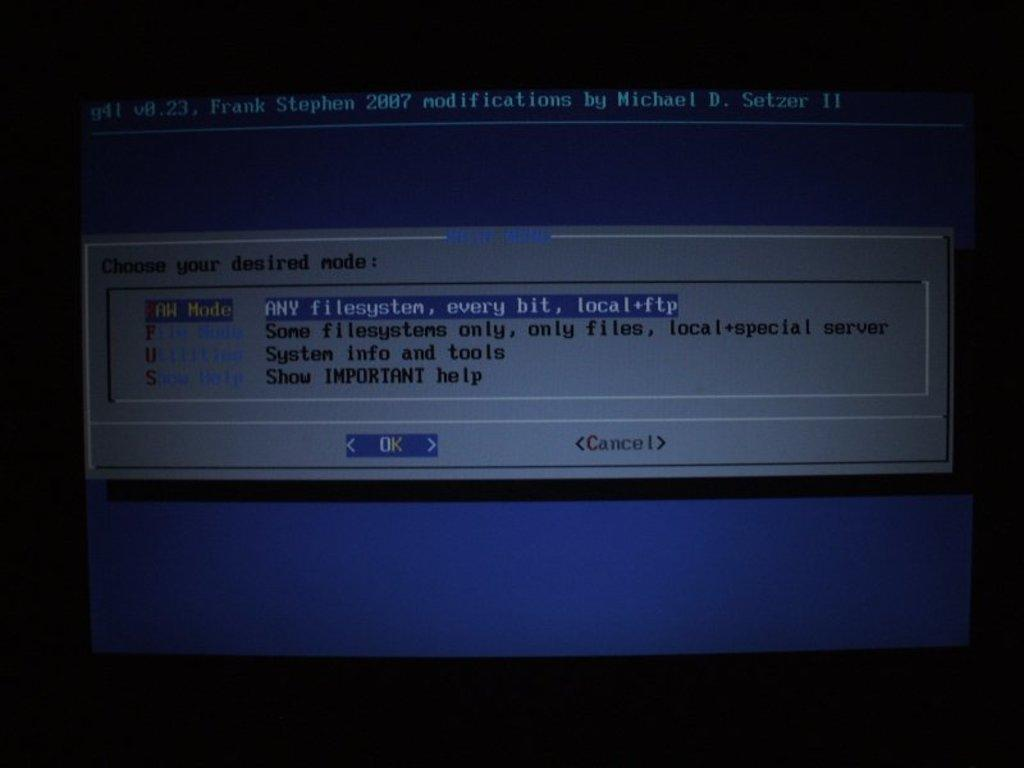<image>
Render a clear and concise summary of the photo. A message on a computer screen asks to Choose your desired mode. 